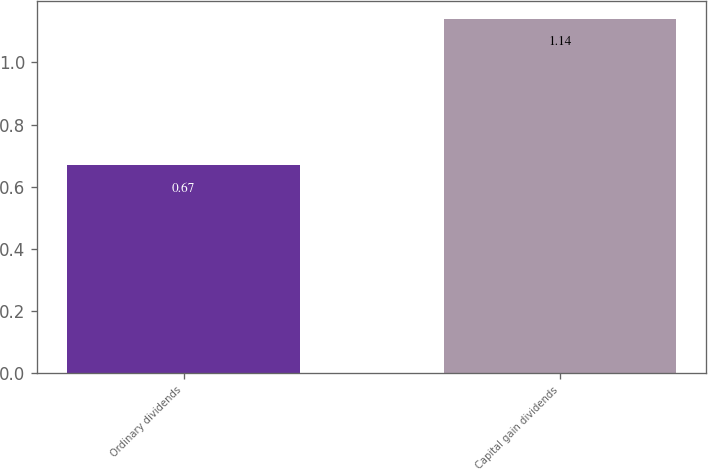<chart> <loc_0><loc_0><loc_500><loc_500><bar_chart><fcel>Ordinary dividends<fcel>Capital gain dividends<nl><fcel>0.67<fcel>1.14<nl></chart> 